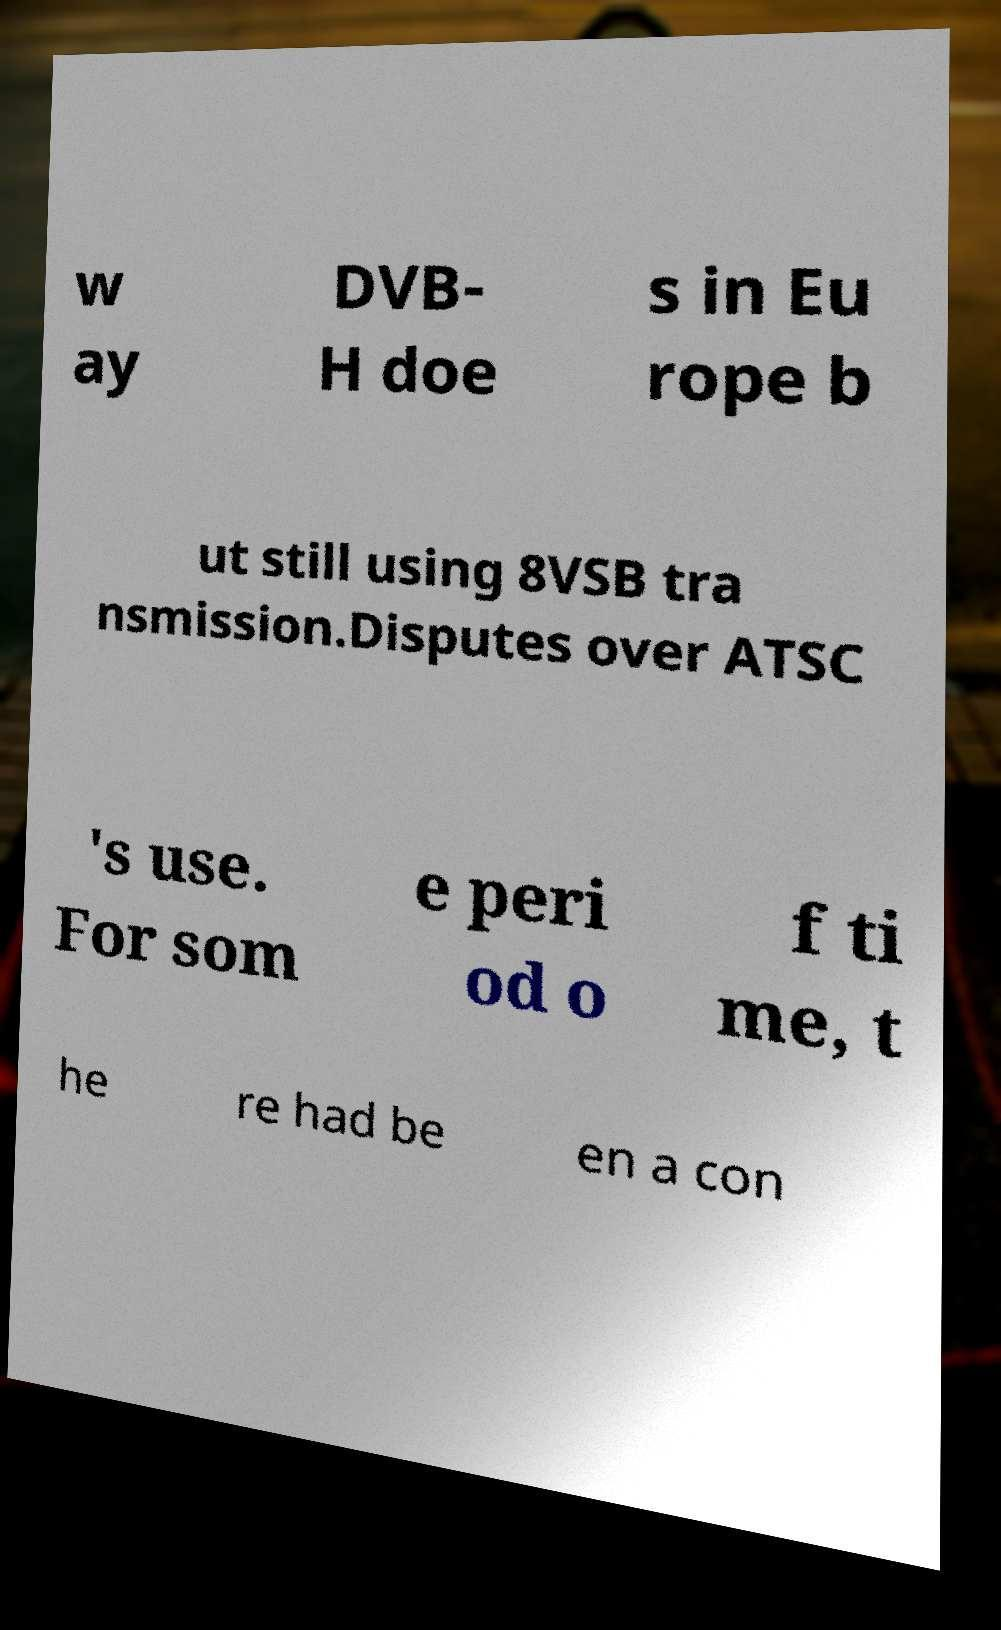Could you extract and type out the text from this image? w ay DVB- H doe s in Eu rope b ut still using 8VSB tra nsmission.Disputes over ATSC 's use. For som e peri od o f ti me, t he re had be en a con 